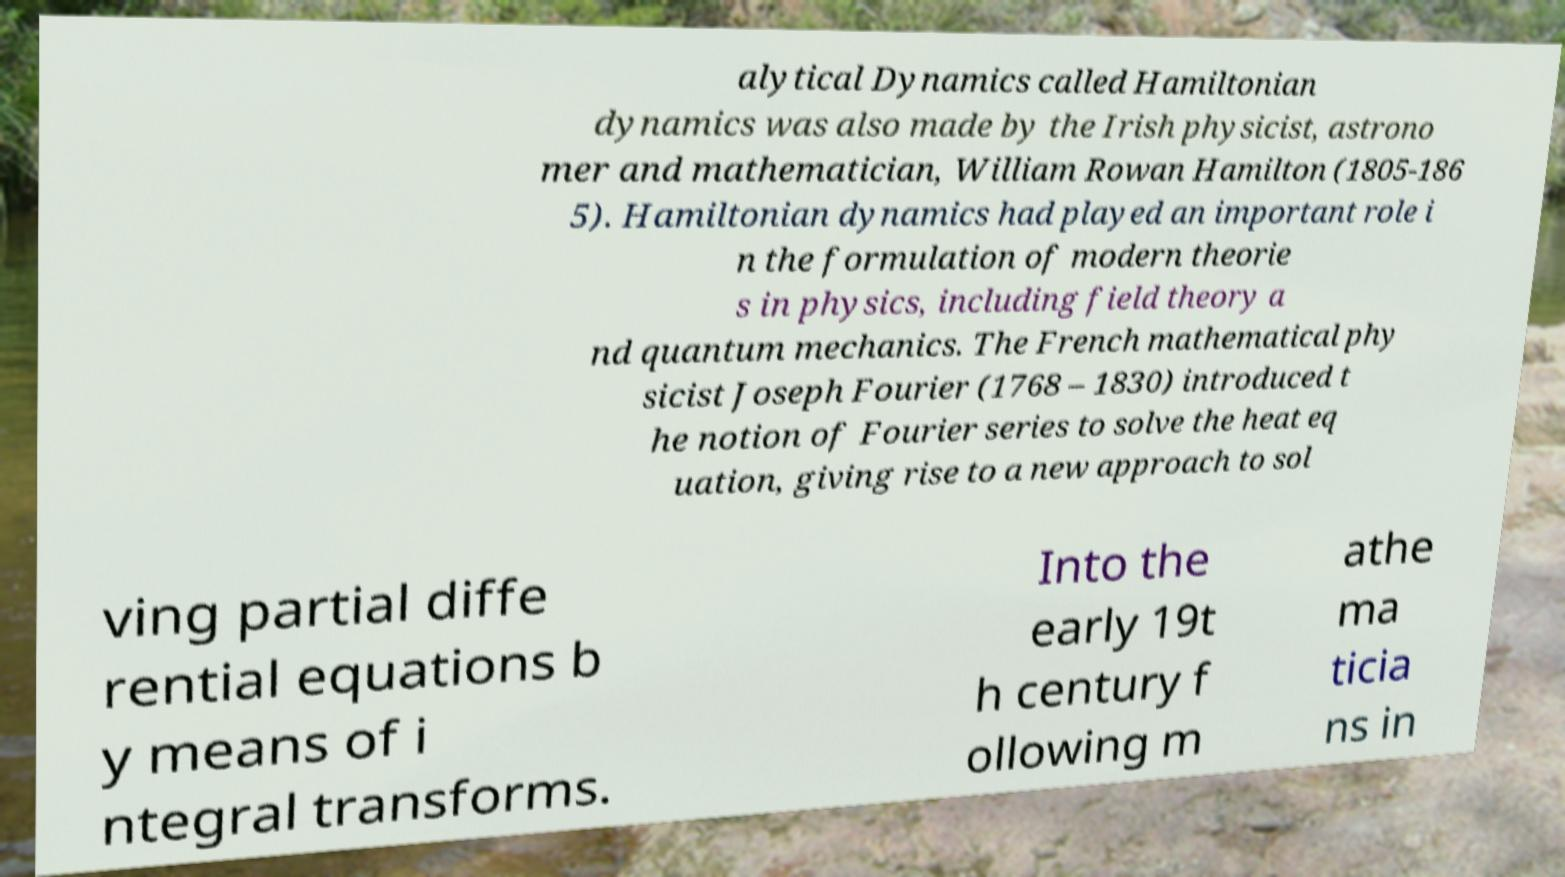I need the written content from this picture converted into text. Can you do that? alytical Dynamics called Hamiltonian dynamics was also made by the Irish physicist, astrono mer and mathematician, William Rowan Hamilton (1805-186 5). Hamiltonian dynamics had played an important role i n the formulation of modern theorie s in physics, including field theory a nd quantum mechanics. The French mathematical phy sicist Joseph Fourier (1768 – 1830) introduced t he notion of Fourier series to solve the heat eq uation, giving rise to a new approach to sol ving partial diffe rential equations b y means of i ntegral transforms. Into the early 19t h century f ollowing m athe ma ticia ns in 